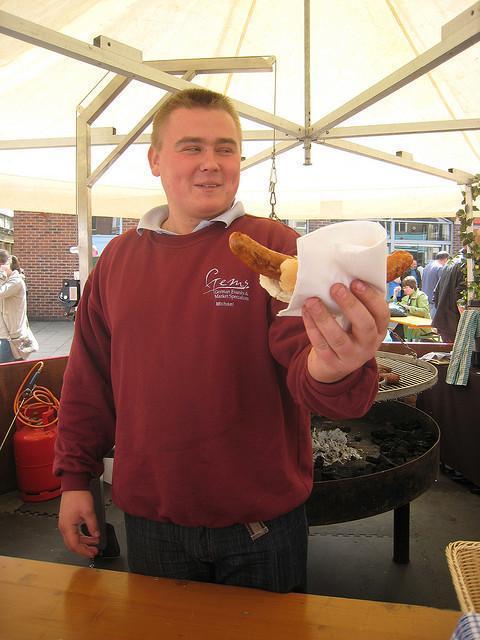How many people are visible?
Give a very brief answer. 3. How many suitcases are shown?
Give a very brief answer. 0. 